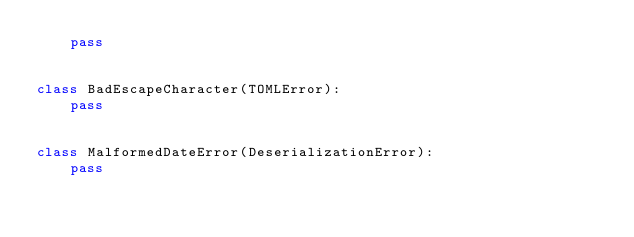<code> <loc_0><loc_0><loc_500><loc_500><_Python_>    pass


class BadEscapeCharacter(TOMLError):
    pass


class MalformedDateError(DeserializationError):
    pass
</code> 